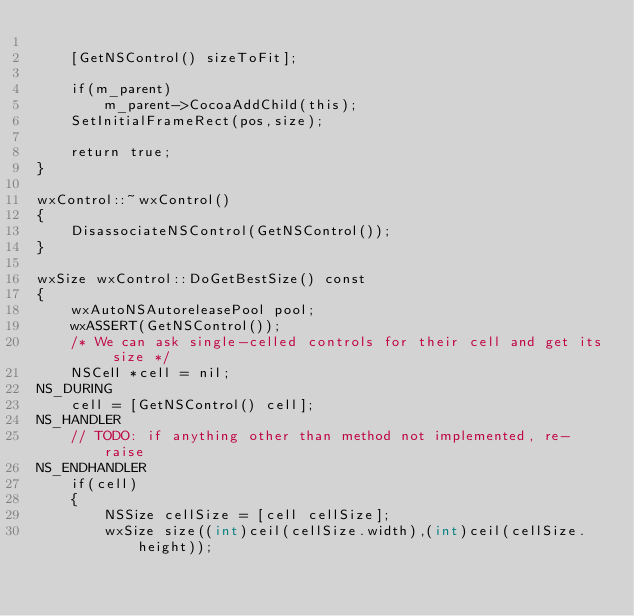<code> <loc_0><loc_0><loc_500><loc_500><_ObjectiveC_>
    [GetNSControl() sizeToFit];

    if(m_parent)
        m_parent->CocoaAddChild(this);
    SetInitialFrameRect(pos,size);

    return true;
}

wxControl::~wxControl()
{
    DisassociateNSControl(GetNSControl());
}

wxSize wxControl::DoGetBestSize() const
{
    wxAutoNSAutoreleasePool pool;
    wxASSERT(GetNSControl());
    /* We can ask single-celled controls for their cell and get its size */
    NSCell *cell = nil;
NS_DURING
    cell = [GetNSControl() cell];
NS_HANDLER
    // TODO: if anything other than method not implemented, re-raise
NS_ENDHANDLER
    if(cell)
    {
        NSSize cellSize = [cell cellSize];
        wxSize size((int)ceil(cellSize.width),(int)ceil(cellSize.height));</code> 